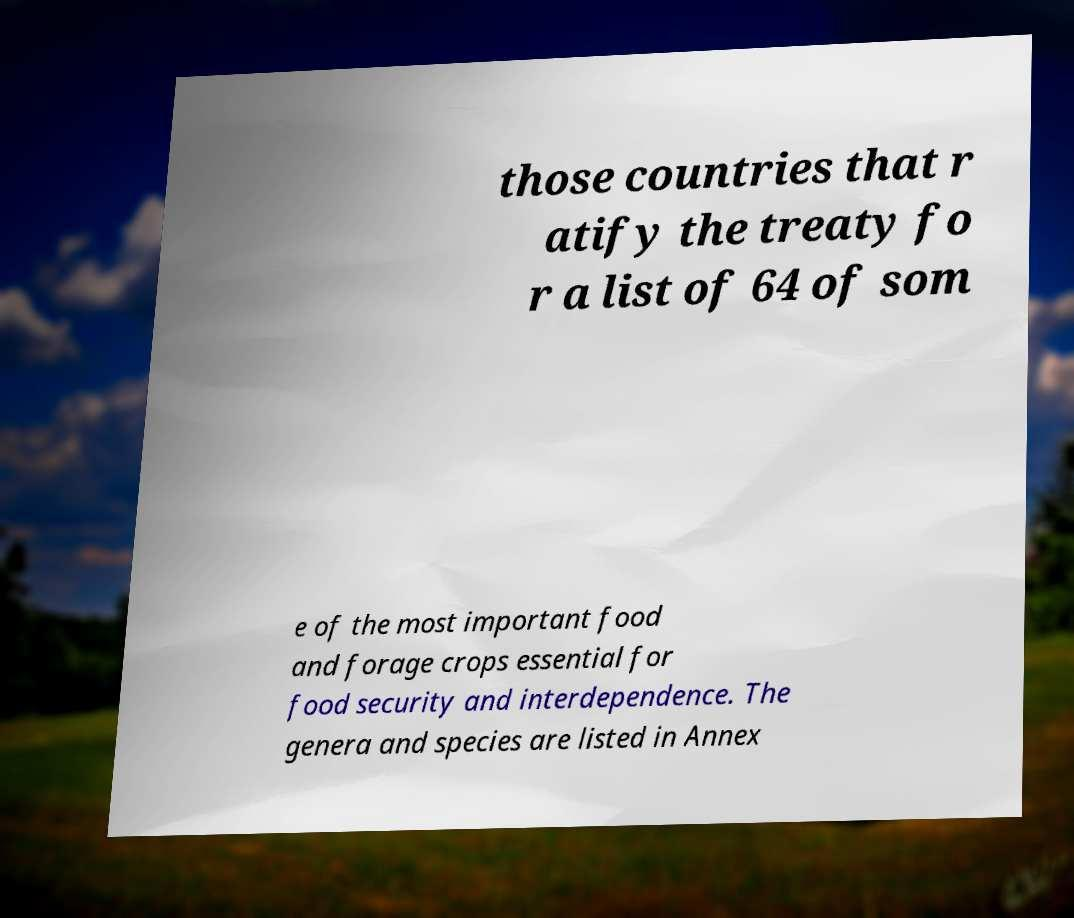Could you assist in decoding the text presented in this image and type it out clearly? those countries that r atify the treaty fo r a list of 64 of som e of the most important food and forage crops essential for food security and interdependence. The genera and species are listed in Annex 